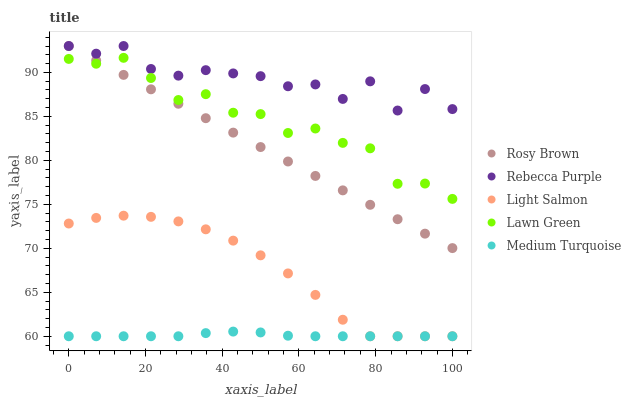Does Medium Turquoise have the minimum area under the curve?
Answer yes or no. Yes. Does Rebecca Purple have the maximum area under the curve?
Answer yes or no. Yes. Does Light Salmon have the minimum area under the curve?
Answer yes or no. No. Does Light Salmon have the maximum area under the curve?
Answer yes or no. No. Is Rosy Brown the smoothest?
Answer yes or no. Yes. Is Rebecca Purple the roughest?
Answer yes or no. Yes. Is Light Salmon the smoothest?
Answer yes or no. No. Is Light Salmon the roughest?
Answer yes or no. No. Does Light Salmon have the lowest value?
Answer yes or no. Yes. Does Rosy Brown have the lowest value?
Answer yes or no. No. Does Rebecca Purple have the highest value?
Answer yes or no. Yes. Does Light Salmon have the highest value?
Answer yes or no. No. Is Medium Turquoise less than Rebecca Purple?
Answer yes or no. Yes. Is Rebecca Purple greater than Medium Turquoise?
Answer yes or no. Yes. Does Rebecca Purple intersect Rosy Brown?
Answer yes or no. Yes. Is Rebecca Purple less than Rosy Brown?
Answer yes or no. No. Is Rebecca Purple greater than Rosy Brown?
Answer yes or no. No. Does Medium Turquoise intersect Rebecca Purple?
Answer yes or no. No. 